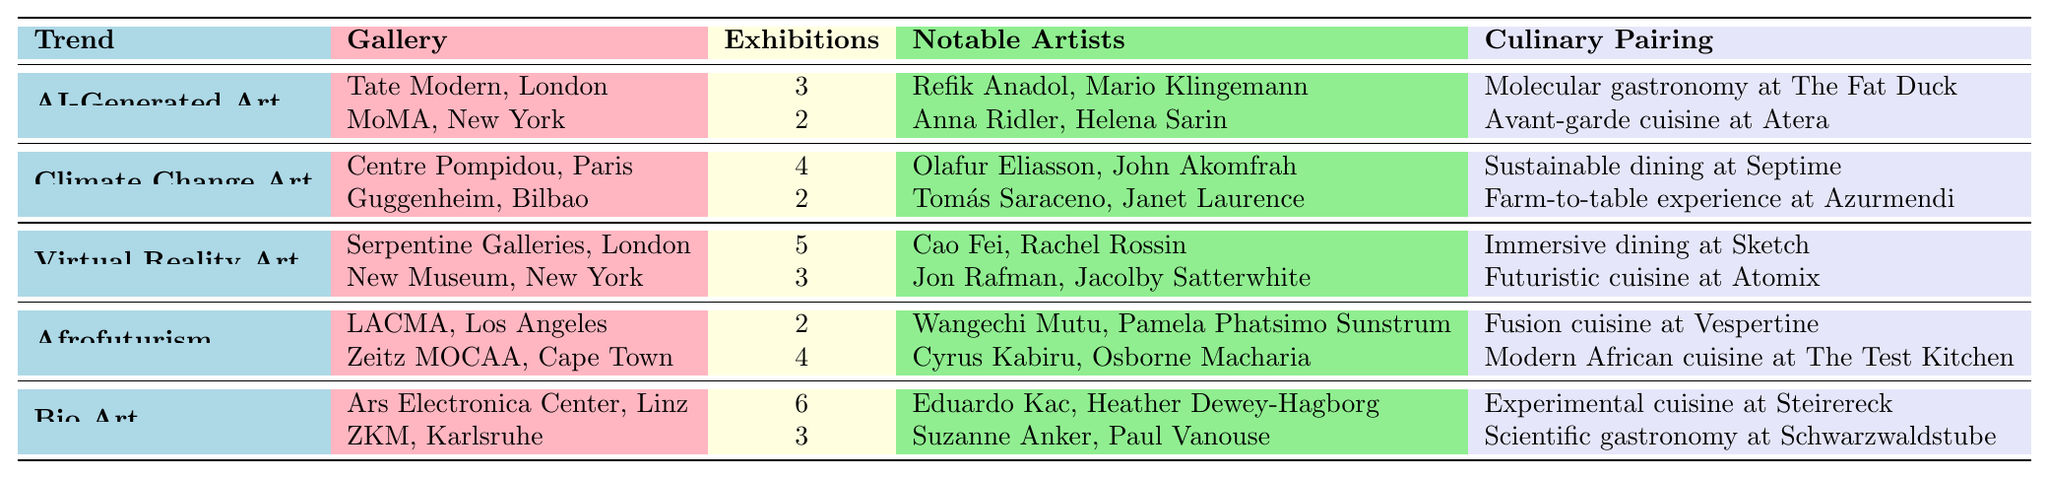What is the total number of exhibitions for AI-Generated Art? In the table, the total number of exhibitions for AI-Generated Art can be found by summing the exhibitions from both galleries. Tate Modern has 3 exhibitions, and MoMA has 2 exhibitions, so the total is 3 + 2 = 5.
Answer: 5 Which gallery has the most exhibitions for Bio Art? The table lists Ars Electronica Center with 6 exhibitions and ZKM with 3. Since 6 is greater than 3, Ars Electronica Center has the most exhibitions for Bio Art.
Answer: Ars Electronica Center How many notable artists are associated with Climate Change Art in total? For Climate Change Art, there are two galleries listed: Centre Pompidou has 2 notable artists, and Guggenheim has 2 notable artists. Adding these gives 2 + 2 = 4 notable artists in total.
Answer: 4 Is Molecular gastronomy paired with any other trend besides AI-Generated Art? The table shows that Molecular gastronomy at The Fat Duck is specifically paired with AI-Generated Art. Other trends have different culinary pairings, making this statement false.
Answer: No What's the average number of exhibitions across all trends in the data? To find the average, first sum the number of exhibitions by trend: AI-Generated Art (5) + Climate Change Art (6) + Virtual Reality Art (8) + Afrofuturism (6) + Bio Art (9) = 34 exhibitions. There are 5 trends, so the average is 34/5 = 6.8.
Answer: 6.8 How many notable artists are represented in galleries located in New York? The notable artists for galleries in New York include: MoMA (2) and New Museum (2), totaling 2 + 2 = 4 notable artists.
Answer: 4 Which emerging art trend has the highest representation in terms of exhibitions? By reviewing the exhibitions for each trend, Bio Art has 6 exhibitions, which is the highest compared to other trends like AI-Generated Art (5), Climate Change Art (6), Virtual Reality Art (8), and Afrofuturism (6).
Answer: Bio Art What is the total number of exhibitions for galleries located in London? The exhibitions in London include Tate Modern with 3 and Serpentine Galleries with 5, totaling 3 + 5 = 8 exhibitions from galleries in London.
Answer: 8 Does Zeitz MOCAA showcase more exhibitions compared to LACMA for Afrofuturism? The data shows Zeitz MOCAA has 4 exhibitions while LACMA has 2. Since 4 is greater than 2, the statement is true.
Answer: Yes What culinary experience pairs with the most exhibitions in Bio Art? The culinary pairing for Bio Art at Ars Electronica Center is Experimental cuisine at Steirereck for 6 exhibitions, which is more than the Scientific gastronomy at Schwarzwaldstube for 3 exhibitions.
Answer: Experimental cuisine at Steirereck 